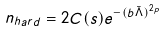Convert formula to latex. <formula><loc_0><loc_0><loc_500><loc_500>n _ { h a r d } = 2 C ( s ) e ^ { - ( b { \bar { \Lambda } } ) ^ { 2 p } }</formula> 